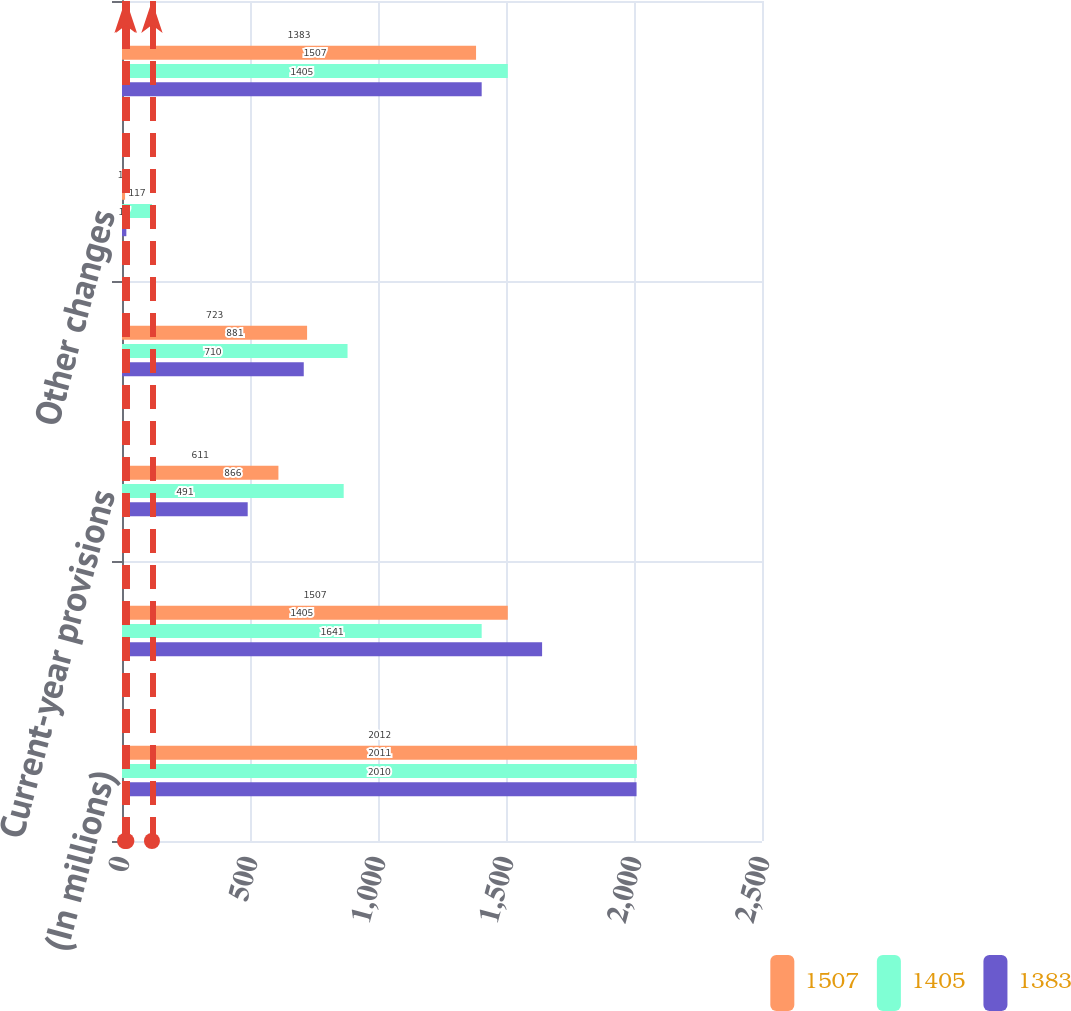<chart> <loc_0><loc_0><loc_500><loc_500><stacked_bar_chart><ecel><fcel>(In millions)<fcel>Balance at January 1<fcel>Current-year provisions<fcel>Expenditures<fcel>Other changes<fcel>Balance at December 31<nl><fcel>1507<fcel>2012<fcel>1507<fcel>611<fcel>723<fcel>12<fcel>1383<nl><fcel>1405<fcel>2011<fcel>1405<fcel>866<fcel>881<fcel>117<fcel>1507<nl><fcel>1383<fcel>2010<fcel>1641<fcel>491<fcel>710<fcel>17<fcel>1405<nl></chart> 